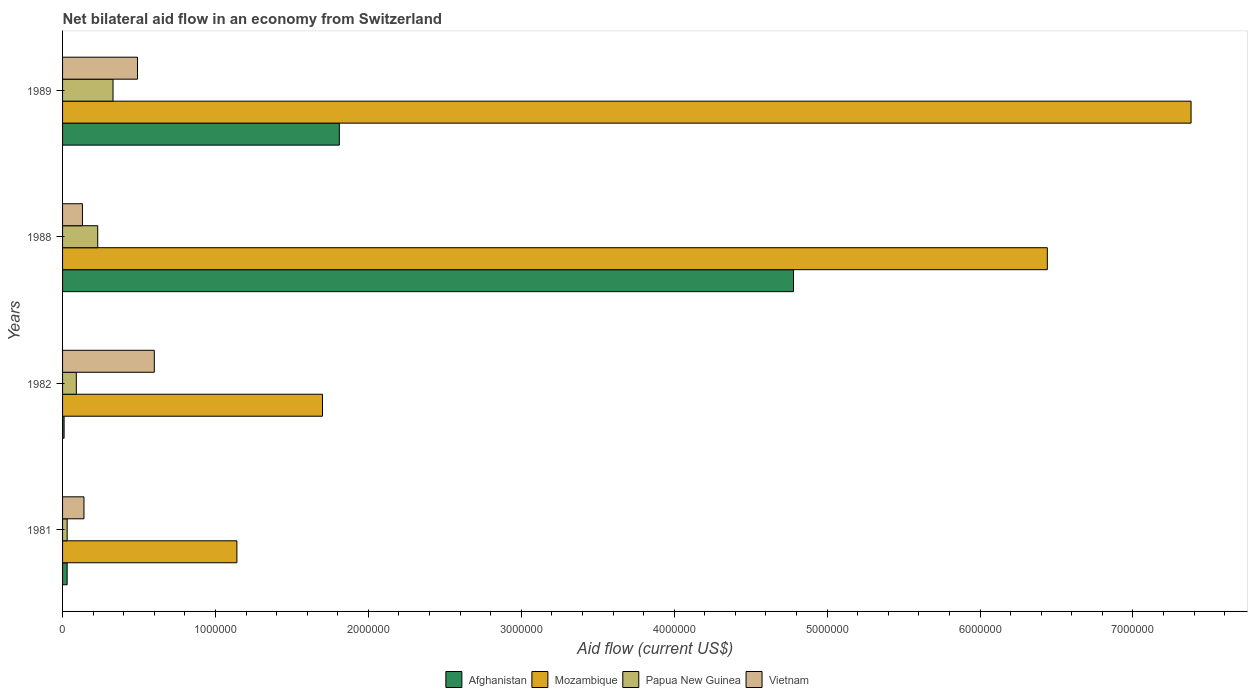How many different coloured bars are there?
Offer a terse response. 4. How many groups of bars are there?
Ensure brevity in your answer.  4. How many bars are there on the 3rd tick from the bottom?
Make the answer very short. 4. What is the label of the 2nd group of bars from the top?
Provide a succinct answer. 1988. In how many cases, is the number of bars for a given year not equal to the number of legend labels?
Provide a succinct answer. 0. What is the net bilateral aid flow in Mozambique in 1989?
Give a very brief answer. 7.38e+06. Across all years, what is the maximum net bilateral aid flow in Vietnam?
Your answer should be compact. 6.00e+05. Across all years, what is the minimum net bilateral aid flow in Papua New Guinea?
Provide a succinct answer. 3.00e+04. In which year was the net bilateral aid flow in Mozambique minimum?
Your answer should be compact. 1981. What is the total net bilateral aid flow in Vietnam in the graph?
Your answer should be compact. 1.36e+06. What is the difference between the net bilateral aid flow in Mozambique in 1981 and that in 1982?
Your response must be concise. -5.60e+05. What is the difference between the net bilateral aid flow in Vietnam in 1981 and the net bilateral aid flow in Mozambique in 1989?
Offer a terse response. -7.24e+06. In the year 1982, what is the difference between the net bilateral aid flow in Vietnam and net bilateral aid flow in Afghanistan?
Offer a very short reply. 5.90e+05. In how many years, is the net bilateral aid flow in Mozambique greater than 5200000 US$?
Offer a terse response. 2. What is the ratio of the net bilateral aid flow in Afghanistan in 1982 to that in 1988?
Your response must be concise. 0. Is the difference between the net bilateral aid flow in Vietnam in 1981 and 1988 greater than the difference between the net bilateral aid flow in Afghanistan in 1981 and 1988?
Keep it short and to the point. Yes. What is the difference between the highest and the second highest net bilateral aid flow in Mozambique?
Give a very brief answer. 9.40e+05. What is the difference between the highest and the lowest net bilateral aid flow in Mozambique?
Your response must be concise. 6.24e+06. In how many years, is the net bilateral aid flow in Mozambique greater than the average net bilateral aid flow in Mozambique taken over all years?
Ensure brevity in your answer.  2. Is the sum of the net bilateral aid flow in Vietnam in 1982 and 1989 greater than the maximum net bilateral aid flow in Papua New Guinea across all years?
Provide a succinct answer. Yes. Is it the case that in every year, the sum of the net bilateral aid flow in Vietnam and net bilateral aid flow in Mozambique is greater than the sum of net bilateral aid flow in Afghanistan and net bilateral aid flow in Papua New Guinea?
Offer a terse response. No. What does the 1st bar from the top in 1989 represents?
Provide a short and direct response. Vietnam. What does the 1st bar from the bottom in 1982 represents?
Ensure brevity in your answer.  Afghanistan. What is the difference between two consecutive major ticks on the X-axis?
Your answer should be compact. 1.00e+06. Does the graph contain grids?
Provide a succinct answer. No. How many legend labels are there?
Ensure brevity in your answer.  4. How are the legend labels stacked?
Provide a short and direct response. Horizontal. What is the title of the graph?
Offer a very short reply. Net bilateral aid flow in an economy from Switzerland. What is the label or title of the Y-axis?
Your response must be concise. Years. What is the Aid flow (current US$) in Afghanistan in 1981?
Your answer should be compact. 3.00e+04. What is the Aid flow (current US$) in Mozambique in 1981?
Provide a short and direct response. 1.14e+06. What is the Aid flow (current US$) in Vietnam in 1981?
Offer a terse response. 1.40e+05. What is the Aid flow (current US$) in Mozambique in 1982?
Your answer should be very brief. 1.70e+06. What is the Aid flow (current US$) in Vietnam in 1982?
Your response must be concise. 6.00e+05. What is the Aid flow (current US$) in Afghanistan in 1988?
Your answer should be very brief. 4.78e+06. What is the Aid flow (current US$) in Mozambique in 1988?
Your answer should be very brief. 6.44e+06. What is the Aid flow (current US$) in Vietnam in 1988?
Make the answer very short. 1.30e+05. What is the Aid flow (current US$) in Afghanistan in 1989?
Provide a short and direct response. 1.81e+06. What is the Aid flow (current US$) of Mozambique in 1989?
Your answer should be very brief. 7.38e+06. What is the Aid flow (current US$) of Papua New Guinea in 1989?
Make the answer very short. 3.30e+05. Across all years, what is the maximum Aid flow (current US$) in Afghanistan?
Give a very brief answer. 4.78e+06. Across all years, what is the maximum Aid flow (current US$) in Mozambique?
Make the answer very short. 7.38e+06. Across all years, what is the maximum Aid flow (current US$) in Vietnam?
Provide a short and direct response. 6.00e+05. Across all years, what is the minimum Aid flow (current US$) in Mozambique?
Your response must be concise. 1.14e+06. Across all years, what is the minimum Aid flow (current US$) in Vietnam?
Give a very brief answer. 1.30e+05. What is the total Aid flow (current US$) of Afghanistan in the graph?
Your response must be concise. 6.63e+06. What is the total Aid flow (current US$) in Mozambique in the graph?
Provide a succinct answer. 1.67e+07. What is the total Aid flow (current US$) of Papua New Guinea in the graph?
Ensure brevity in your answer.  6.80e+05. What is the total Aid flow (current US$) in Vietnam in the graph?
Keep it short and to the point. 1.36e+06. What is the difference between the Aid flow (current US$) in Afghanistan in 1981 and that in 1982?
Your response must be concise. 2.00e+04. What is the difference between the Aid flow (current US$) of Mozambique in 1981 and that in 1982?
Give a very brief answer. -5.60e+05. What is the difference between the Aid flow (current US$) of Papua New Guinea in 1981 and that in 1982?
Give a very brief answer. -6.00e+04. What is the difference between the Aid flow (current US$) of Vietnam in 1981 and that in 1982?
Keep it short and to the point. -4.60e+05. What is the difference between the Aid flow (current US$) in Afghanistan in 1981 and that in 1988?
Offer a very short reply. -4.75e+06. What is the difference between the Aid flow (current US$) of Mozambique in 1981 and that in 1988?
Your answer should be compact. -5.30e+06. What is the difference between the Aid flow (current US$) of Afghanistan in 1981 and that in 1989?
Your answer should be very brief. -1.78e+06. What is the difference between the Aid flow (current US$) of Mozambique in 1981 and that in 1989?
Your answer should be compact. -6.24e+06. What is the difference between the Aid flow (current US$) in Vietnam in 1981 and that in 1989?
Keep it short and to the point. -3.50e+05. What is the difference between the Aid flow (current US$) in Afghanistan in 1982 and that in 1988?
Provide a short and direct response. -4.77e+06. What is the difference between the Aid flow (current US$) in Mozambique in 1982 and that in 1988?
Offer a terse response. -4.74e+06. What is the difference between the Aid flow (current US$) in Afghanistan in 1982 and that in 1989?
Ensure brevity in your answer.  -1.80e+06. What is the difference between the Aid flow (current US$) of Mozambique in 1982 and that in 1989?
Offer a very short reply. -5.68e+06. What is the difference between the Aid flow (current US$) in Papua New Guinea in 1982 and that in 1989?
Offer a very short reply. -2.40e+05. What is the difference between the Aid flow (current US$) of Afghanistan in 1988 and that in 1989?
Your answer should be very brief. 2.97e+06. What is the difference between the Aid flow (current US$) of Mozambique in 1988 and that in 1989?
Ensure brevity in your answer.  -9.40e+05. What is the difference between the Aid flow (current US$) in Vietnam in 1988 and that in 1989?
Offer a terse response. -3.60e+05. What is the difference between the Aid flow (current US$) in Afghanistan in 1981 and the Aid flow (current US$) in Mozambique in 1982?
Your answer should be compact. -1.67e+06. What is the difference between the Aid flow (current US$) of Afghanistan in 1981 and the Aid flow (current US$) of Papua New Guinea in 1982?
Provide a succinct answer. -6.00e+04. What is the difference between the Aid flow (current US$) in Afghanistan in 1981 and the Aid flow (current US$) in Vietnam in 1982?
Keep it short and to the point. -5.70e+05. What is the difference between the Aid flow (current US$) of Mozambique in 1981 and the Aid flow (current US$) of Papua New Guinea in 1982?
Your answer should be compact. 1.05e+06. What is the difference between the Aid flow (current US$) in Mozambique in 1981 and the Aid flow (current US$) in Vietnam in 1982?
Your answer should be very brief. 5.40e+05. What is the difference between the Aid flow (current US$) in Papua New Guinea in 1981 and the Aid flow (current US$) in Vietnam in 1982?
Your answer should be very brief. -5.70e+05. What is the difference between the Aid flow (current US$) of Afghanistan in 1981 and the Aid flow (current US$) of Mozambique in 1988?
Provide a succinct answer. -6.41e+06. What is the difference between the Aid flow (current US$) in Afghanistan in 1981 and the Aid flow (current US$) in Papua New Guinea in 1988?
Give a very brief answer. -2.00e+05. What is the difference between the Aid flow (current US$) of Mozambique in 1981 and the Aid flow (current US$) of Papua New Guinea in 1988?
Give a very brief answer. 9.10e+05. What is the difference between the Aid flow (current US$) in Mozambique in 1981 and the Aid flow (current US$) in Vietnam in 1988?
Make the answer very short. 1.01e+06. What is the difference between the Aid flow (current US$) in Afghanistan in 1981 and the Aid flow (current US$) in Mozambique in 1989?
Offer a very short reply. -7.35e+06. What is the difference between the Aid flow (current US$) of Afghanistan in 1981 and the Aid flow (current US$) of Papua New Guinea in 1989?
Keep it short and to the point. -3.00e+05. What is the difference between the Aid flow (current US$) of Afghanistan in 1981 and the Aid flow (current US$) of Vietnam in 1989?
Offer a very short reply. -4.60e+05. What is the difference between the Aid flow (current US$) of Mozambique in 1981 and the Aid flow (current US$) of Papua New Guinea in 1989?
Ensure brevity in your answer.  8.10e+05. What is the difference between the Aid flow (current US$) in Mozambique in 1981 and the Aid flow (current US$) in Vietnam in 1989?
Offer a very short reply. 6.50e+05. What is the difference between the Aid flow (current US$) in Papua New Guinea in 1981 and the Aid flow (current US$) in Vietnam in 1989?
Keep it short and to the point. -4.60e+05. What is the difference between the Aid flow (current US$) in Afghanistan in 1982 and the Aid flow (current US$) in Mozambique in 1988?
Offer a terse response. -6.43e+06. What is the difference between the Aid flow (current US$) in Afghanistan in 1982 and the Aid flow (current US$) in Vietnam in 1988?
Provide a succinct answer. -1.20e+05. What is the difference between the Aid flow (current US$) of Mozambique in 1982 and the Aid flow (current US$) of Papua New Guinea in 1988?
Provide a short and direct response. 1.47e+06. What is the difference between the Aid flow (current US$) of Mozambique in 1982 and the Aid flow (current US$) of Vietnam in 1988?
Provide a succinct answer. 1.57e+06. What is the difference between the Aid flow (current US$) in Papua New Guinea in 1982 and the Aid flow (current US$) in Vietnam in 1988?
Your answer should be compact. -4.00e+04. What is the difference between the Aid flow (current US$) of Afghanistan in 1982 and the Aid flow (current US$) of Mozambique in 1989?
Your answer should be compact. -7.37e+06. What is the difference between the Aid flow (current US$) in Afghanistan in 1982 and the Aid flow (current US$) in Papua New Guinea in 1989?
Ensure brevity in your answer.  -3.20e+05. What is the difference between the Aid flow (current US$) of Afghanistan in 1982 and the Aid flow (current US$) of Vietnam in 1989?
Your response must be concise. -4.80e+05. What is the difference between the Aid flow (current US$) in Mozambique in 1982 and the Aid flow (current US$) in Papua New Guinea in 1989?
Ensure brevity in your answer.  1.37e+06. What is the difference between the Aid flow (current US$) in Mozambique in 1982 and the Aid flow (current US$) in Vietnam in 1989?
Keep it short and to the point. 1.21e+06. What is the difference between the Aid flow (current US$) of Papua New Guinea in 1982 and the Aid flow (current US$) of Vietnam in 1989?
Provide a succinct answer. -4.00e+05. What is the difference between the Aid flow (current US$) of Afghanistan in 1988 and the Aid flow (current US$) of Mozambique in 1989?
Keep it short and to the point. -2.60e+06. What is the difference between the Aid flow (current US$) in Afghanistan in 1988 and the Aid flow (current US$) in Papua New Guinea in 1989?
Your answer should be very brief. 4.45e+06. What is the difference between the Aid flow (current US$) of Afghanistan in 1988 and the Aid flow (current US$) of Vietnam in 1989?
Your response must be concise. 4.29e+06. What is the difference between the Aid flow (current US$) in Mozambique in 1988 and the Aid flow (current US$) in Papua New Guinea in 1989?
Give a very brief answer. 6.11e+06. What is the difference between the Aid flow (current US$) in Mozambique in 1988 and the Aid flow (current US$) in Vietnam in 1989?
Your answer should be compact. 5.95e+06. What is the difference between the Aid flow (current US$) in Papua New Guinea in 1988 and the Aid flow (current US$) in Vietnam in 1989?
Provide a succinct answer. -2.60e+05. What is the average Aid flow (current US$) in Afghanistan per year?
Offer a terse response. 1.66e+06. What is the average Aid flow (current US$) of Mozambique per year?
Keep it short and to the point. 4.16e+06. What is the average Aid flow (current US$) in Papua New Guinea per year?
Give a very brief answer. 1.70e+05. In the year 1981, what is the difference between the Aid flow (current US$) in Afghanistan and Aid flow (current US$) in Mozambique?
Keep it short and to the point. -1.11e+06. In the year 1981, what is the difference between the Aid flow (current US$) in Mozambique and Aid flow (current US$) in Papua New Guinea?
Give a very brief answer. 1.11e+06. In the year 1982, what is the difference between the Aid flow (current US$) of Afghanistan and Aid flow (current US$) of Mozambique?
Your answer should be very brief. -1.69e+06. In the year 1982, what is the difference between the Aid flow (current US$) in Afghanistan and Aid flow (current US$) in Vietnam?
Offer a terse response. -5.90e+05. In the year 1982, what is the difference between the Aid flow (current US$) of Mozambique and Aid flow (current US$) of Papua New Guinea?
Give a very brief answer. 1.61e+06. In the year 1982, what is the difference between the Aid flow (current US$) in Mozambique and Aid flow (current US$) in Vietnam?
Offer a terse response. 1.10e+06. In the year 1982, what is the difference between the Aid flow (current US$) in Papua New Guinea and Aid flow (current US$) in Vietnam?
Make the answer very short. -5.10e+05. In the year 1988, what is the difference between the Aid flow (current US$) of Afghanistan and Aid flow (current US$) of Mozambique?
Keep it short and to the point. -1.66e+06. In the year 1988, what is the difference between the Aid flow (current US$) in Afghanistan and Aid flow (current US$) in Papua New Guinea?
Your response must be concise. 4.55e+06. In the year 1988, what is the difference between the Aid flow (current US$) in Afghanistan and Aid flow (current US$) in Vietnam?
Provide a succinct answer. 4.65e+06. In the year 1988, what is the difference between the Aid flow (current US$) in Mozambique and Aid flow (current US$) in Papua New Guinea?
Your answer should be very brief. 6.21e+06. In the year 1988, what is the difference between the Aid flow (current US$) of Mozambique and Aid flow (current US$) of Vietnam?
Give a very brief answer. 6.31e+06. In the year 1989, what is the difference between the Aid flow (current US$) in Afghanistan and Aid flow (current US$) in Mozambique?
Ensure brevity in your answer.  -5.57e+06. In the year 1989, what is the difference between the Aid flow (current US$) in Afghanistan and Aid flow (current US$) in Papua New Guinea?
Ensure brevity in your answer.  1.48e+06. In the year 1989, what is the difference between the Aid flow (current US$) of Afghanistan and Aid flow (current US$) of Vietnam?
Offer a terse response. 1.32e+06. In the year 1989, what is the difference between the Aid flow (current US$) in Mozambique and Aid flow (current US$) in Papua New Guinea?
Keep it short and to the point. 7.05e+06. In the year 1989, what is the difference between the Aid flow (current US$) of Mozambique and Aid flow (current US$) of Vietnam?
Your answer should be very brief. 6.89e+06. What is the ratio of the Aid flow (current US$) in Afghanistan in 1981 to that in 1982?
Offer a terse response. 3. What is the ratio of the Aid flow (current US$) of Mozambique in 1981 to that in 1982?
Keep it short and to the point. 0.67. What is the ratio of the Aid flow (current US$) of Papua New Guinea in 1981 to that in 1982?
Provide a short and direct response. 0.33. What is the ratio of the Aid flow (current US$) of Vietnam in 1981 to that in 1982?
Offer a terse response. 0.23. What is the ratio of the Aid flow (current US$) in Afghanistan in 1981 to that in 1988?
Ensure brevity in your answer.  0.01. What is the ratio of the Aid flow (current US$) in Mozambique in 1981 to that in 1988?
Offer a terse response. 0.18. What is the ratio of the Aid flow (current US$) in Papua New Guinea in 1981 to that in 1988?
Offer a terse response. 0.13. What is the ratio of the Aid flow (current US$) of Vietnam in 1981 to that in 1988?
Provide a short and direct response. 1.08. What is the ratio of the Aid flow (current US$) in Afghanistan in 1981 to that in 1989?
Provide a succinct answer. 0.02. What is the ratio of the Aid flow (current US$) in Mozambique in 1981 to that in 1989?
Your answer should be very brief. 0.15. What is the ratio of the Aid flow (current US$) of Papua New Guinea in 1981 to that in 1989?
Give a very brief answer. 0.09. What is the ratio of the Aid flow (current US$) in Vietnam in 1981 to that in 1989?
Ensure brevity in your answer.  0.29. What is the ratio of the Aid flow (current US$) in Afghanistan in 1982 to that in 1988?
Provide a short and direct response. 0. What is the ratio of the Aid flow (current US$) of Mozambique in 1982 to that in 1988?
Provide a succinct answer. 0.26. What is the ratio of the Aid flow (current US$) in Papua New Guinea in 1982 to that in 1988?
Make the answer very short. 0.39. What is the ratio of the Aid flow (current US$) in Vietnam in 1982 to that in 1988?
Make the answer very short. 4.62. What is the ratio of the Aid flow (current US$) in Afghanistan in 1982 to that in 1989?
Offer a terse response. 0.01. What is the ratio of the Aid flow (current US$) of Mozambique in 1982 to that in 1989?
Provide a short and direct response. 0.23. What is the ratio of the Aid flow (current US$) of Papua New Guinea in 1982 to that in 1989?
Keep it short and to the point. 0.27. What is the ratio of the Aid flow (current US$) of Vietnam in 1982 to that in 1989?
Your answer should be very brief. 1.22. What is the ratio of the Aid flow (current US$) of Afghanistan in 1988 to that in 1989?
Give a very brief answer. 2.64. What is the ratio of the Aid flow (current US$) of Mozambique in 1988 to that in 1989?
Offer a very short reply. 0.87. What is the ratio of the Aid flow (current US$) in Papua New Guinea in 1988 to that in 1989?
Your answer should be very brief. 0.7. What is the ratio of the Aid flow (current US$) of Vietnam in 1988 to that in 1989?
Ensure brevity in your answer.  0.27. What is the difference between the highest and the second highest Aid flow (current US$) in Afghanistan?
Keep it short and to the point. 2.97e+06. What is the difference between the highest and the second highest Aid flow (current US$) in Mozambique?
Ensure brevity in your answer.  9.40e+05. What is the difference between the highest and the second highest Aid flow (current US$) of Vietnam?
Your answer should be compact. 1.10e+05. What is the difference between the highest and the lowest Aid flow (current US$) of Afghanistan?
Keep it short and to the point. 4.77e+06. What is the difference between the highest and the lowest Aid flow (current US$) of Mozambique?
Ensure brevity in your answer.  6.24e+06. What is the difference between the highest and the lowest Aid flow (current US$) in Papua New Guinea?
Your answer should be compact. 3.00e+05. 